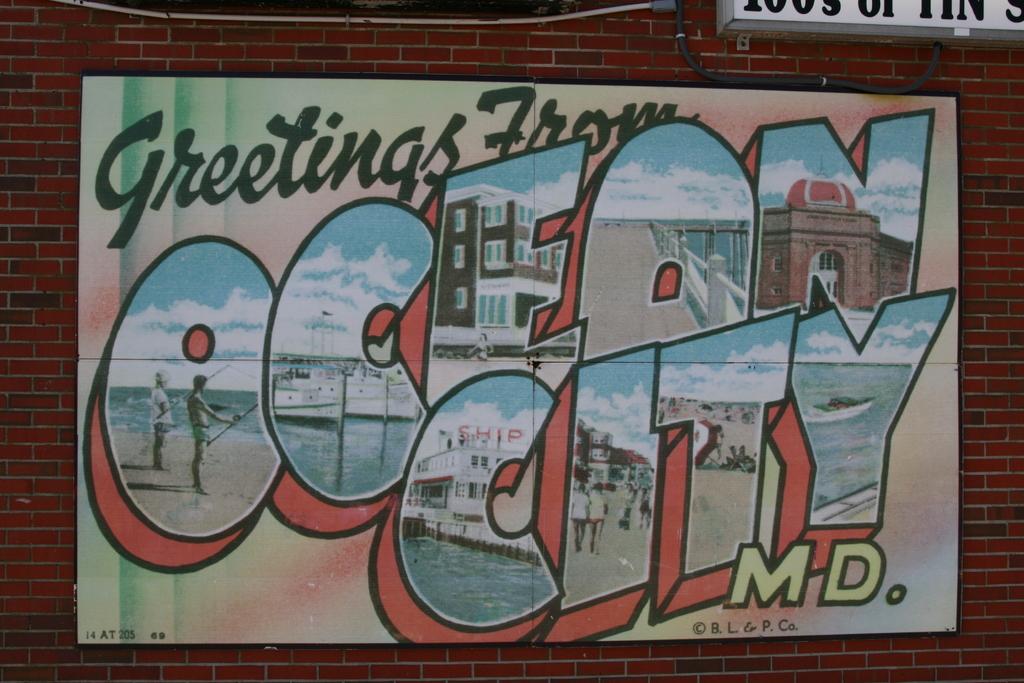Which state is ocean city in?
Offer a very short reply. Maryland. Is this a greeting card?
Keep it short and to the point. Yes. 